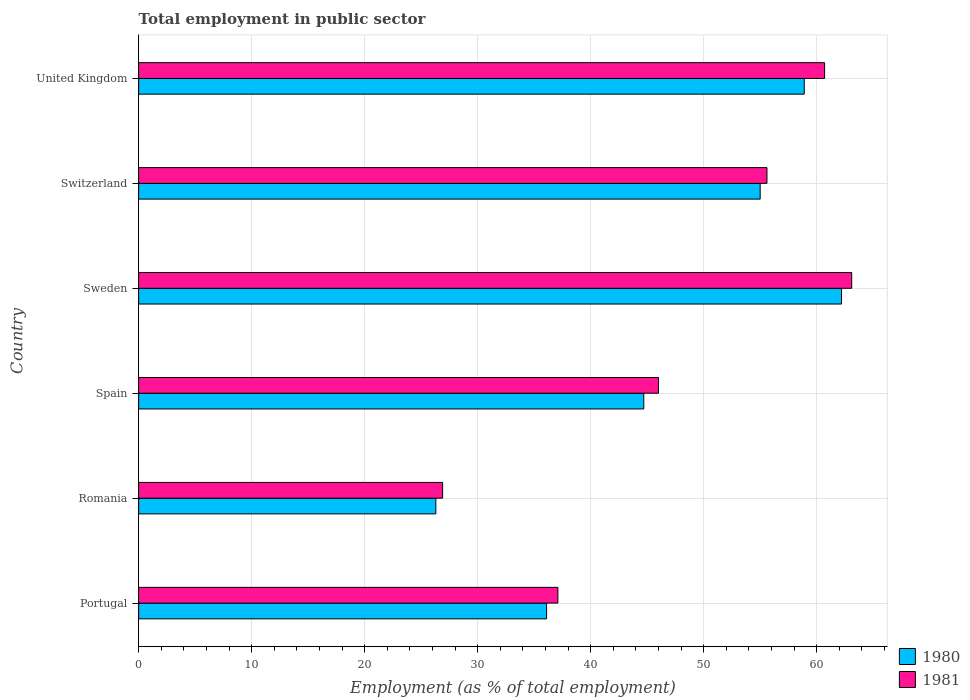How many different coloured bars are there?
Give a very brief answer. 2. Are the number of bars per tick equal to the number of legend labels?
Provide a succinct answer. Yes. Are the number of bars on each tick of the Y-axis equal?
Your answer should be very brief. Yes. How many bars are there on the 6th tick from the top?
Provide a short and direct response. 2. How many bars are there on the 2nd tick from the bottom?
Provide a short and direct response. 2. What is the label of the 3rd group of bars from the top?
Your answer should be compact. Sweden. What is the employment in public sector in 1980 in Spain?
Provide a short and direct response. 44.7. Across all countries, what is the maximum employment in public sector in 1980?
Make the answer very short. 62.2. Across all countries, what is the minimum employment in public sector in 1981?
Your response must be concise. 26.9. In which country was the employment in public sector in 1981 maximum?
Ensure brevity in your answer.  Sweden. In which country was the employment in public sector in 1981 minimum?
Provide a succinct answer. Romania. What is the total employment in public sector in 1981 in the graph?
Your answer should be very brief. 289.4. What is the difference between the employment in public sector in 1980 in Portugal and that in Sweden?
Your response must be concise. -26.1. What is the difference between the employment in public sector in 1980 in Portugal and the employment in public sector in 1981 in Spain?
Provide a succinct answer. -9.9. What is the average employment in public sector in 1981 per country?
Your answer should be very brief. 48.23. What is the difference between the employment in public sector in 1980 and employment in public sector in 1981 in United Kingdom?
Keep it short and to the point. -1.8. What is the ratio of the employment in public sector in 1980 in Sweden to that in Switzerland?
Make the answer very short. 1.13. What is the difference between the highest and the second highest employment in public sector in 1980?
Keep it short and to the point. 3.3. What is the difference between the highest and the lowest employment in public sector in 1981?
Make the answer very short. 36.2. In how many countries, is the employment in public sector in 1980 greater than the average employment in public sector in 1980 taken over all countries?
Provide a short and direct response. 3. Is the sum of the employment in public sector in 1981 in Sweden and United Kingdom greater than the maximum employment in public sector in 1980 across all countries?
Your answer should be very brief. Yes. What does the 2nd bar from the top in Portugal represents?
Keep it short and to the point. 1980. What does the 1st bar from the bottom in Romania represents?
Ensure brevity in your answer.  1980. Are all the bars in the graph horizontal?
Your answer should be compact. Yes. Are the values on the major ticks of X-axis written in scientific E-notation?
Provide a succinct answer. No. Does the graph contain any zero values?
Keep it short and to the point. No. Does the graph contain grids?
Offer a very short reply. Yes. How are the legend labels stacked?
Your response must be concise. Vertical. What is the title of the graph?
Offer a very short reply. Total employment in public sector. What is the label or title of the X-axis?
Provide a succinct answer. Employment (as % of total employment). What is the label or title of the Y-axis?
Your answer should be very brief. Country. What is the Employment (as % of total employment) of 1980 in Portugal?
Provide a short and direct response. 36.1. What is the Employment (as % of total employment) of 1981 in Portugal?
Ensure brevity in your answer.  37.1. What is the Employment (as % of total employment) in 1980 in Romania?
Keep it short and to the point. 26.3. What is the Employment (as % of total employment) in 1981 in Romania?
Ensure brevity in your answer.  26.9. What is the Employment (as % of total employment) of 1980 in Spain?
Your response must be concise. 44.7. What is the Employment (as % of total employment) in 1981 in Spain?
Provide a short and direct response. 46. What is the Employment (as % of total employment) in 1980 in Sweden?
Make the answer very short. 62.2. What is the Employment (as % of total employment) of 1981 in Sweden?
Provide a short and direct response. 63.1. What is the Employment (as % of total employment) in 1981 in Switzerland?
Ensure brevity in your answer.  55.6. What is the Employment (as % of total employment) in 1980 in United Kingdom?
Your answer should be very brief. 58.9. What is the Employment (as % of total employment) in 1981 in United Kingdom?
Provide a short and direct response. 60.7. Across all countries, what is the maximum Employment (as % of total employment) of 1980?
Your response must be concise. 62.2. Across all countries, what is the maximum Employment (as % of total employment) in 1981?
Keep it short and to the point. 63.1. Across all countries, what is the minimum Employment (as % of total employment) in 1980?
Keep it short and to the point. 26.3. Across all countries, what is the minimum Employment (as % of total employment) of 1981?
Offer a very short reply. 26.9. What is the total Employment (as % of total employment) in 1980 in the graph?
Give a very brief answer. 283.2. What is the total Employment (as % of total employment) in 1981 in the graph?
Provide a succinct answer. 289.4. What is the difference between the Employment (as % of total employment) of 1980 in Portugal and that in Romania?
Ensure brevity in your answer.  9.8. What is the difference between the Employment (as % of total employment) of 1981 in Portugal and that in Romania?
Offer a terse response. 10.2. What is the difference between the Employment (as % of total employment) of 1981 in Portugal and that in Spain?
Keep it short and to the point. -8.9. What is the difference between the Employment (as % of total employment) in 1980 in Portugal and that in Sweden?
Your answer should be compact. -26.1. What is the difference between the Employment (as % of total employment) in 1981 in Portugal and that in Sweden?
Provide a short and direct response. -26. What is the difference between the Employment (as % of total employment) in 1980 in Portugal and that in Switzerland?
Give a very brief answer. -18.9. What is the difference between the Employment (as % of total employment) of 1981 in Portugal and that in Switzerland?
Give a very brief answer. -18.5. What is the difference between the Employment (as % of total employment) of 1980 in Portugal and that in United Kingdom?
Offer a terse response. -22.8. What is the difference between the Employment (as % of total employment) of 1981 in Portugal and that in United Kingdom?
Provide a succinct answer. -23.6. What is the difference between the Employment (as % of total employment) of 1980 in Romania and that in Spain?
Make the answer very short. -18.4. What is the difference between the Employment (as % of total employment) of 1981 in Romania and that in Spain?
Your response must be concise. -19.1. What is the difference between the Employment (as % of total employment) of 1980 in Romania and that in Sweden?
Offer a very short reply. -35.9. What is the difference between the Employment (as % of total employment) in 1981 in Romania and that in Sweden?
Provide a succinct answer. -36.2. What is the difference between the Employment (as % of total employment) of 1980 in Romania and that in Switzerland?
Provide a short and direct response. -28.7. What is the difference between the Employment (as % of total employment) of 1981 in Romania and that in Switzerland?
Provide a succinct answer. -28.7. What is the difference between the Employment (as % of total employment) of 1980 in Romania and that in United Kingdom?
Make the answer very short. -32.6. What is the difference between the Employment (as % of total employment) in 1981 in Romania and that in United Kingdom?
Your answer should be compact. -33.8. What is the difference between the Employment (as % of total employment) in 1980 in Spain and that in Sweden?
Your response must be concise. -17.5. What is the difference between the Employment (as % of total employment) of 1981 in Spain and that in Sweden?
Make the answer very short. -17.1. What is the difference between the Employment (as % of total employment) of 1980 in Spain and that in Switzerland?
Offer a terse response. -10.3. What is the difference between the Employment (as % of total employment) in 1981 in Spain and that in Switzerland?
Ensure brevity in your answer.  -9.6. What is the difference between the Employment (as % of total employment) in 1981 in Spain and that in United Kingdom?
Keep it short and to the point. -14.7. What is the difference between the Employment (as % of total employment) of 1980 in Sweden and that in United Kingdom?
Offer a very short reply. 3.3. What is the difference between the Employment (as % of total employment) in 1981 in Switzerland and that in United Kingdom?
Ensure brevity in your answer.  -5.1. What is the difference between the Employment (as % of total employment) of 1980 in Portugal and the Employment (as % of total employment) of 1981 in Romania?
Your answer should be compact. 9.2. What is the difference between the Employment (as % of total employment) in 1980 in Portugal and the Employment (as % of total employment) in 1981 in Sweden?
Provide a succinct answer. -27. What is the difference between the Employment (as % of total employment) of 1980 in Portugal and the Employment (as % of total employment) of 1981 in Switzerland?
Offer a very short reply. -19.5. What is the difference between the Employment (as % of total employment) of 1980 in Portugal and the Employment (as % of total employment) of 1981 in United Kingdom?
Your answer should be compact. -24.6. What is the difference between the Employment (as % of total employment) in 1980 in Romania and the Employment (as % of total employment) in 1981 in Spain?
Give a very brief answer. -19.7. What is the difference between the Employment (as % of total employment) of 1980 in Romania and the Employment (as % of total employment) of 1981 in Sweden?
Your answer should be compact. -36.8. What is the difference between the Employment (as % of total employment) in 1980 in Romania and the Employment (as % of total employment) in 1981 in Switzerland?
Provide a succinct answer. -29.3. What is the difference between the Employment (as % of total employment) in 1980 in Romania and the Employment (as % of total employment) in 1981 in United Kingdom?
Provide a short and direct response. -34.4. What is the difference between the Employment (as % of total employment) in 1980 in Spain and the Employment (as % of total employment) in 1981 in Sweden?
Your answer should be very brief. -18.4. What is the difference between the Employment (as % of total employment) in 1980 in Spain and the Employment (as % of total employment) in 1981 in United Kingdom?
Your answer should be compact. -16. What is the difference between the Employment (as % of total employment) in 1980 in Sweden and the Employment (as % of total employment) in 1981 in United Kingdom?
Make the answer very short. 1.5. What is the average Employment (as % of total employment) of 1980 per country?
Provide a succinct answer. 47.2. What is the average Employment (as % of total employment) of 1981 per country?
Ensure brevity in your answer.  48.23. What is the difference between the Employment (as % of total employment) of 1980 and Employment (as % of total employment) of 1981 in Romania?
Give a very brief answer. -0.6. What is the ratio of the Employment (as % of total employment) in 1980 in Portugal to that in Romania?
Offer a terse response. 1.37. What is the ratio of the Employment (as % of total employment) in 1981 in Portugal to that in Romania?
Your answer should be very brief. 1.38. What is the ratio of the Employment (as % of total employment) in 1980 in Portugal to that in Spain?
Make the answer very short. 0.81. What is the ratio of the Employment (as % of total employment) of 1981 in Portugal to that in Spain?
Offer a very short reply. 0.81. What is the ratio of the Employment (as % of total employment) in 1980 in Portugal to that in Sweden?
Keep it short and to the point. 0.58. What is the ratio of the Employment (as % of total employment) of 1981 in Portugal to that in Sweden?
Offer a terse response. 0.59. What is the ratio of the Employment (as % of total employment) of 1980 in Portugal to that in Switzerland?
Provide a succinct answer. 0.66. What is the ratio of the Employment (as % of total employment) in 1981 in Portugal to that in Switzerland?
Offer a very short reply. 0.67. What is the ratio of the Employment (as % of total employment) of 1980 in Portugal to that in United Kingdom?
Provide a short and direct response. 0.61. What is the ratio of the Employment (as % of total employment) in 1981 in Portugal to that in United Kingdom?
Offer a very short reply. 0.61. What is the ratio of the Employment (as % of total employment) of 1980 in Romania to that in Spain?
Offer a very short reply. 0.59. What is the ratio of the Employment (as % of total employment) of 1981 in Romania to that in Spain?
Keep it short and to the point. 0.58. What is the ratio of the Employment (as % of total employment) in 1980 in Romania to that in Sweden?
Provide a succinct answer. 0.42. What is the ratio of the Employment (as % of total employment) in 1981 in Romania to that in Sweden?
Provide a short and direct response. 0.43. What is the ratio of the Employment (as % of total employment) of 1980 in Romania to that in Switzerland?
Keep it short and to the point. 0.48. What is the ratio of the Employment (as % of total employment) of 1981 in Romania to that in Switzerland?
Offer a terse response. 0.48. What is the ratio of the Employment (as % of total employment) in 1980 in Romania to that in United Kingdom?
Ensure brevity in your answer.  0.45. What is the ratio of the Employment (as % of total employment) in 1981 in Romania to that in United Kingdom?
Your answer should be very brief. 0.44. What is the ratio of the Employment (as % of total employment) in 1980 in Spain to that in Sweden?
Give a very brief answer. 0.72. What is the ratio of the Employment (as % of total employment) in 1981 in Spain to that in Sweden?
Your answer should be very brief. 0.73. What is the ratio of the Employment (as % of total employment) of 1980 in Spain to that in Switzerland?
Keep it short and to the point. 0.81. What is the ratio of the Employment (as % of total employment) of 1981 in Spain to that in Switzerland?
Provide a succinct answer. 0.83. What is the ratio of the Employment (as % of total employment) in 1980 in Spain to that in United Kingdom?
Give a very brief answer. 0.76. What is the ratio of the Employment (as % of total employment) of 1981 in Spain to that in United Kingdom?
Make the answer very short. 0.76. What is the ratio of the Employment (as % of total employment) of 1980 in Sweden to that in Switzerland?
Provide a short and direct response. 1.13. What is the ratio of the Employment (as % of total employment) of 1981 in Sweden to that in Switzerland?
Your answer should be compact. 1.13. What is the ratio of the Employment (as % of total employment) of 1980 in Sweden to that in United Kingdom?
Offer a terse response. 1.06. What is the ratio of the Employment (as % of total employment) of 1981 in Sweden to that in United Kingdom?
Your answer should be very brief. 1.04. What is the ratio of the Employment (as % of total employment) in 1980 in Switzerland to that in United Kingdom?
Make the answer very short. 0.93. What is the ratio of the Employment (as % of total employment) of 1981 in Switzerland to that in United Kingdom?
Your response must be concise. 0.92. What is the difference between the highest and the second highest Employment (as % of total employment) of 1980?
Make the answer very short. 3.3. What is the difference between the highest and the lowest Employment (as % of total employment) in 1980?
Your answer should be compact. 35.9. What is the difference between the highest and the lowest Employment (as % of total employment) in 1981?
Your response must be concise. 36.2. 